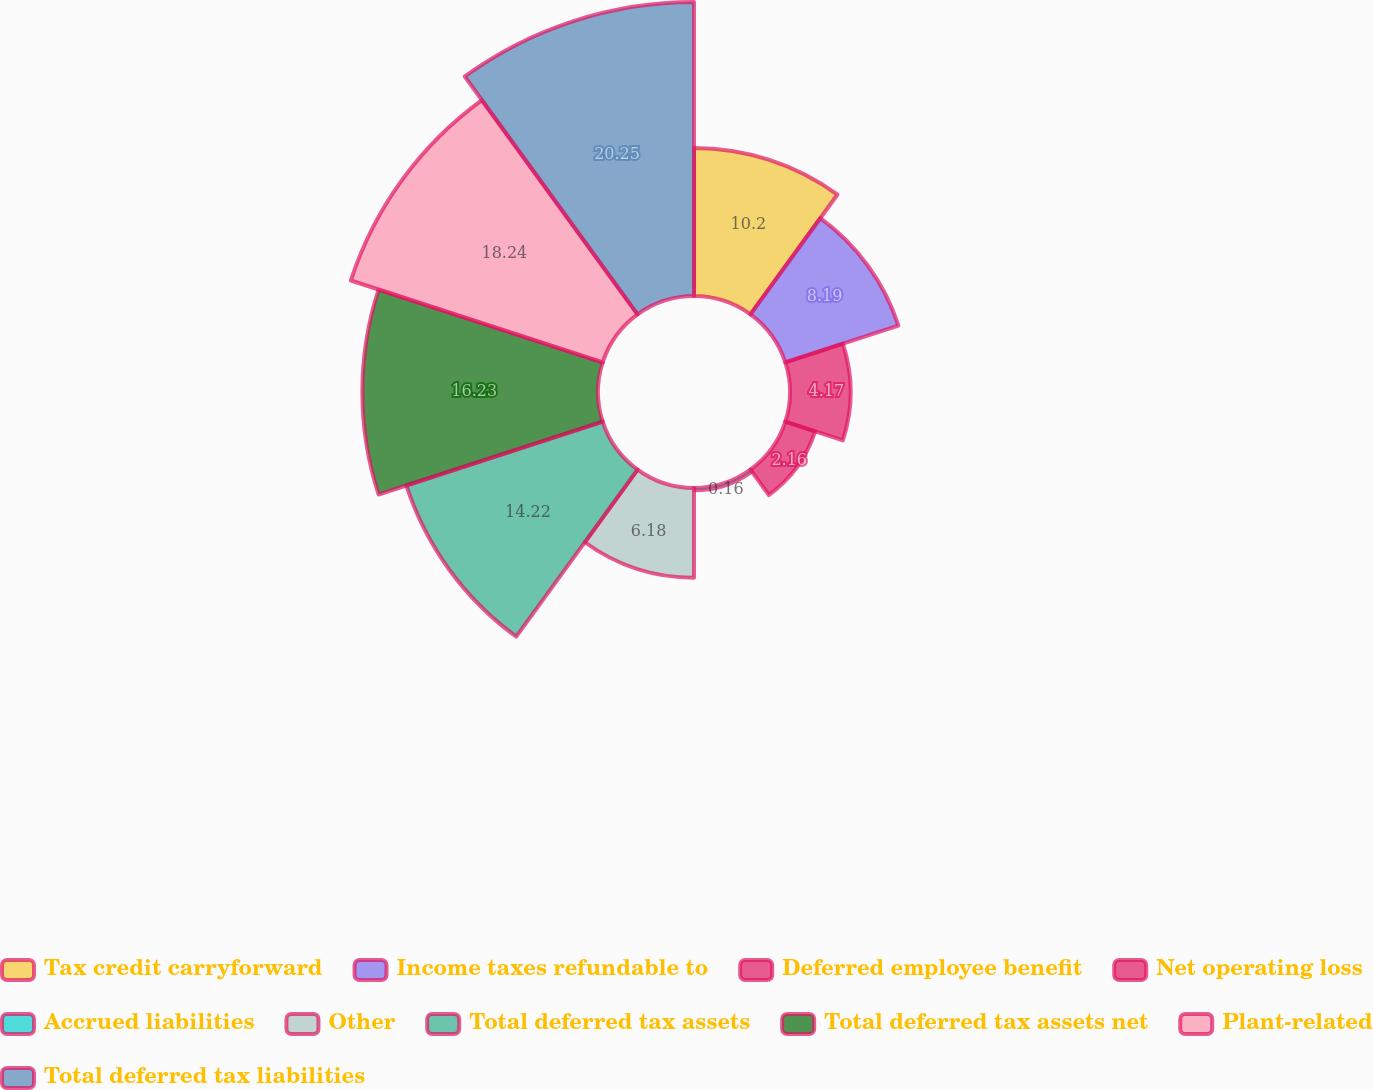<chart> <loc_0><loc_0><loc_500><loc_500><pie_chart><fcel>Tax credit carryforward<fcel>Income taxes refundable to<fcel>Deferred employee benefit<fcel>Net operating loss<fcel>Accrued liabilities<fcel>Other<fcel>Total deferred tax assets<fcel>Total deferred tax assets net<fcel>Plant-related<fcel>Total deferred tax liabilities<nl><fcel>10.2%<fcel>8.19%<fcel>4.17%<fcel>2.16%<fcel>0.16%<fcel>6.18%<fcel>14.22%<fcel>16.23%<fcel>18.24%<fcel>20.25%<nl></chart> 